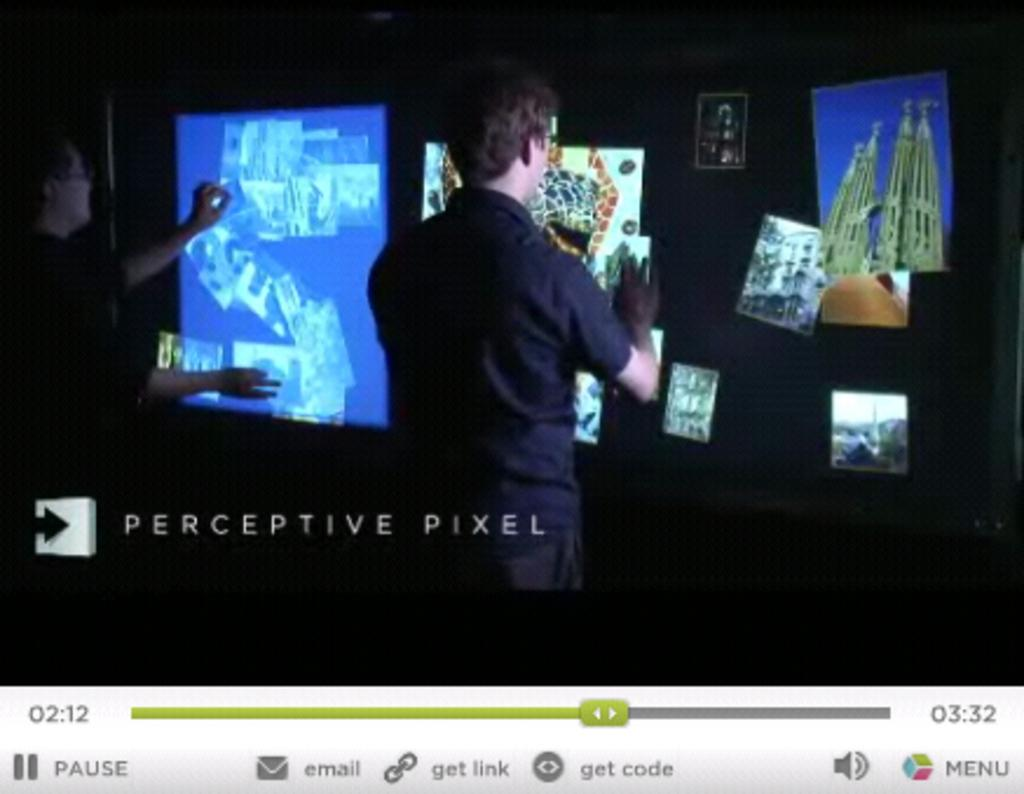<image>
Render a clear and concise summary of the photo. Perceptive Pixel shows a large touch screen.in use. 